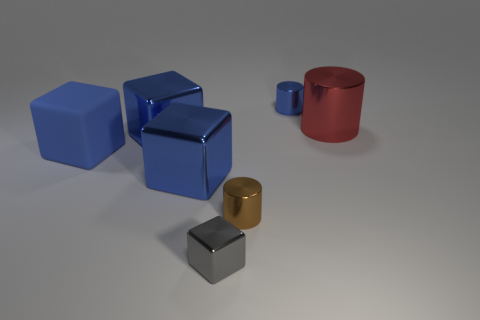Subtract all gray spheres. How many blue blocks are left? 3 Add 1 small metallic blocks. How many objects exist? 8 Subtract all brown cylinders. Subtract all cyan balls. How many cylinders are left? 2 Subtract all cubes. How many objects are left? 3 Add 1 big green metallic cubes. How many big green metallic cubes exist? 1 Subtract 0 brown spheres. How many objects are left? 7 Subtract all small purple metallic cylinders. Subtract all tiny brown metal objects. How many objects are left? 6 Add 2 blue rubber blocks. How many blue rubber blocks are left? 3 